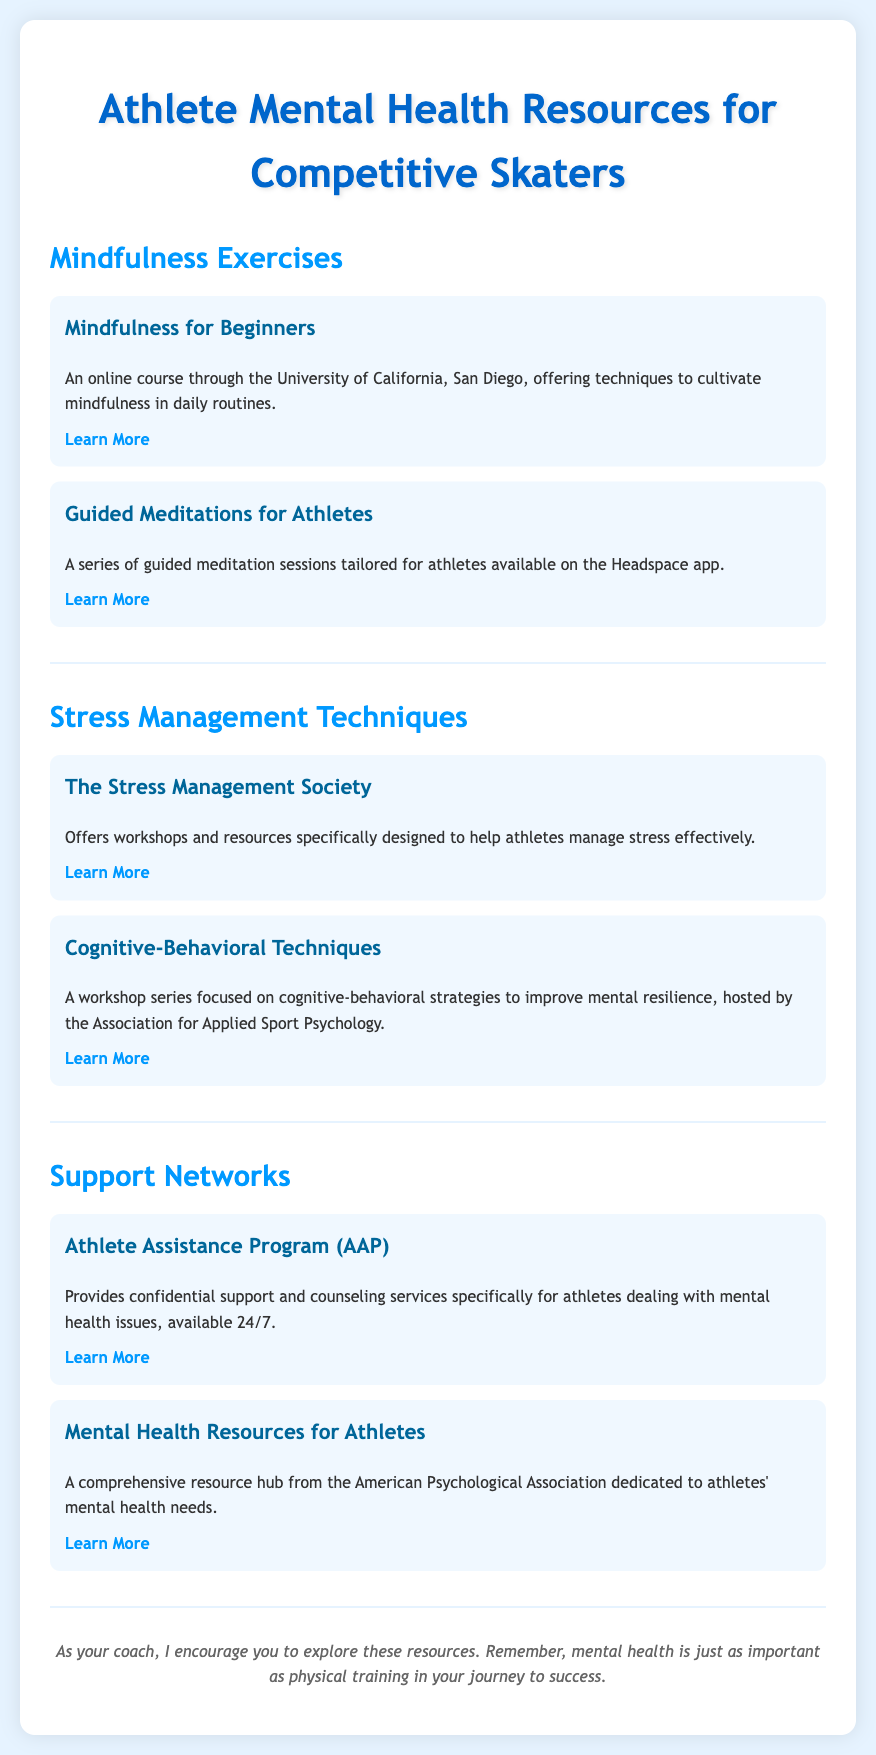What is the title of the document? The title of the document is stated prominently at the top, indicating the focus on mental health resources for athletes.
Answer: Athlete Mental Health Resources for Competitive Skaters How many mindfulness exercises are listed? There are two mindfulness exercises mentioned in the document under the section for mindfulness exercises.
Answer: 2 What organization offers cognitive-behavioral techniques workshops? The workshops for cognitive-behavioral techniques are hosted by a specific professional body related to applied sport psychology.
Answer: Association for Applied Sport Psychology What kind of support does the Athlete Assistance Program provide? The document describes the services offered by the Athlete Assistance Program as confidential support and counseling specifically for athletes dealing with mental health issues.
Answer: Counseling Which app provides guided meditations for athletes? A specific app is indicated in the document for guided meditation sessions tailored for athletes.
Answer: Headspace What is the main focus of the resources provided in the document? The resources compiled in the document are designed to promote the mental well-being of competitive skaters through various strategies and support options.
Answer: Mental health Who is encouraged to explore these resources? The closing note of the document indicates who is encouraged to explore the resources provided throughout the sections.
Answer: Athletes What color is the heading of the document? The color of the main heading is described in the style section of the document, determining its visual presentation.
Answer: #0066cc 